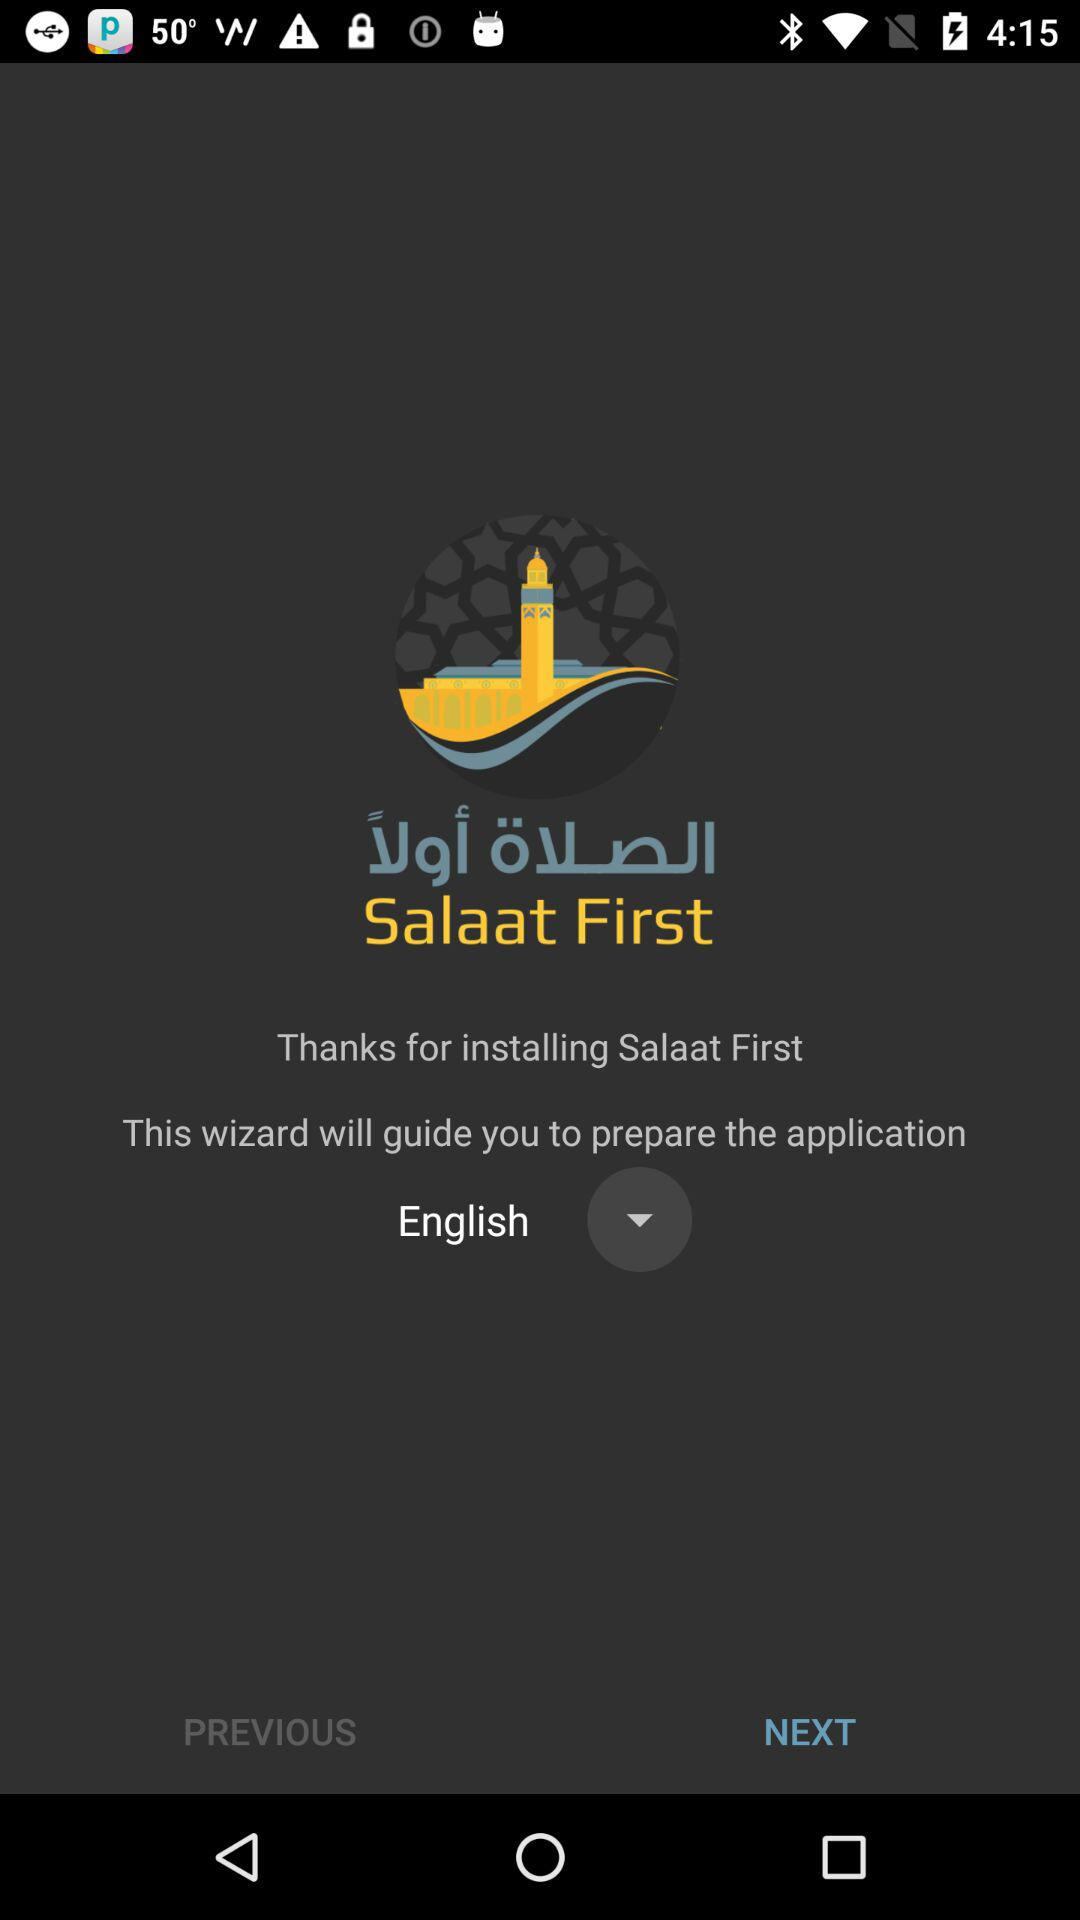What is the application name? The application name is "Salaat First". 